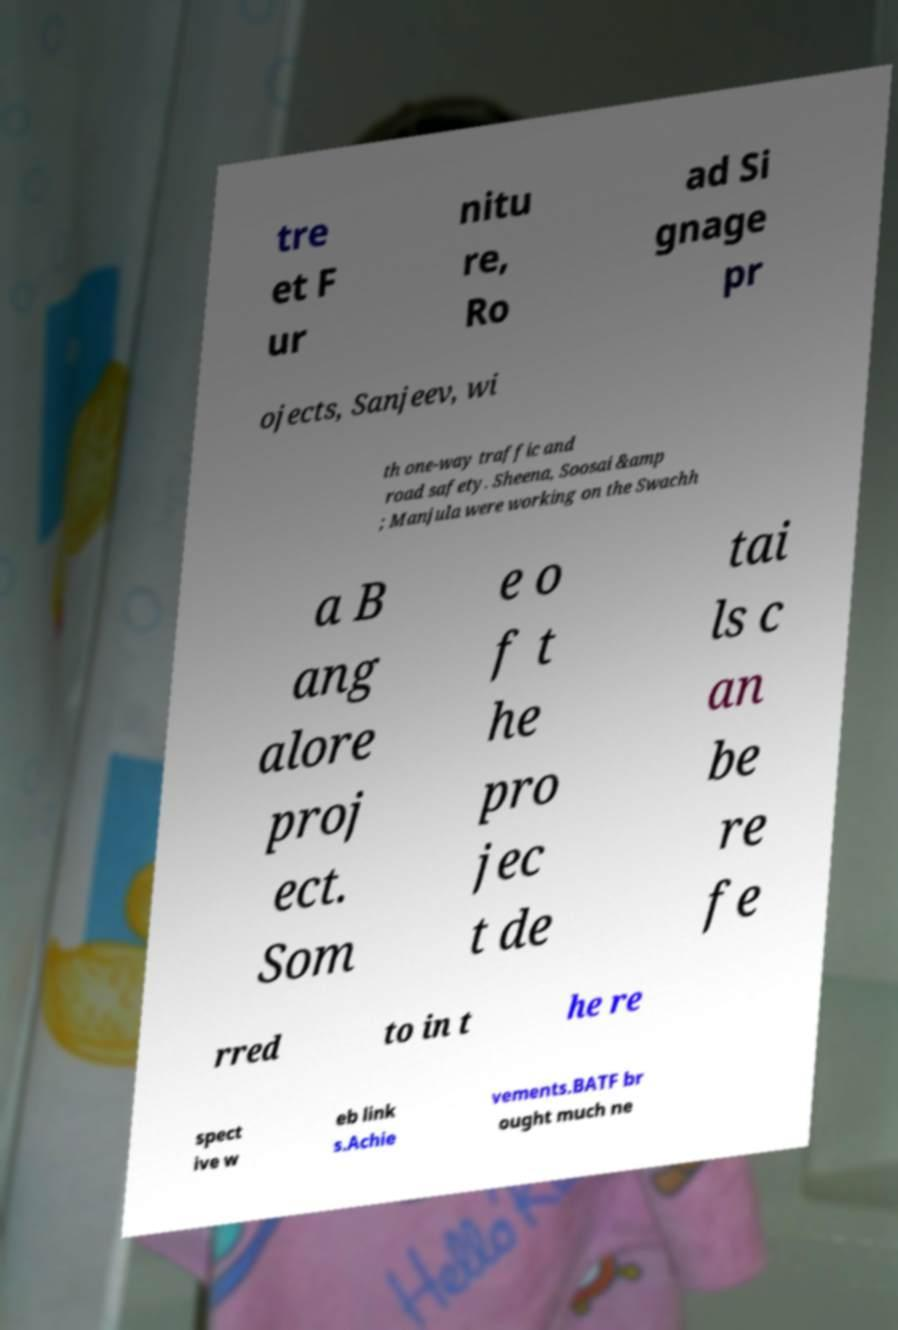What messages or text are displayed in this image? I need them in a readable, typed format. tre et F ur nitu re, Ro ad Si gnage pr ojects, Sanjeev, wi th one-way traffic and road safety. Sheena, Soosai &amp ; Manjula were working on the Swachh a B ang alore proj ect. Som e o f t he pro jec t de tai ls c an be re fe rred to in t he re spect ive w eb link s.Achie vements.BATF br ought much ne 